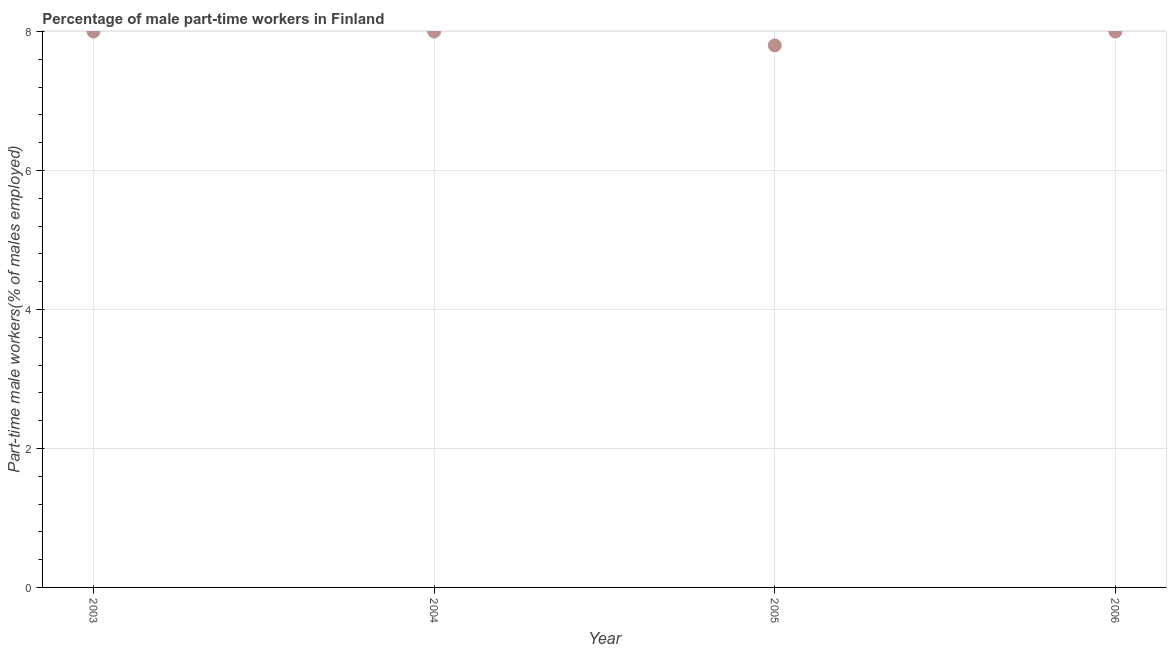What is the percentage of part-time male workers in 2005?
Give a very brief answer. 7.8. Across all years, what is the minimum percentage of part-time male workers?
Provide a short and direct response. 7.8. In which year was the percentage of part-time male workers minimum?
Your answer should be compact. 2005. What is the sum of the percentage of part-time male workers?
Provide a short and direct response. 31.8. What is the average percentage of part-time male workers per year?
Give a very brief answer. 7.95. What is the median percentage of part-time male workers?
Offer a terse response. 8. What is the ratio of the percentage of part-time male workers in 2003 to that in 2005?
Provide a short and direct response. 1.03. Is the percentage of part-time male workers in 2004 less than that in 2006?
Your answer should be compact. No. Is the sum of the percentage of part-time male workers in 2005 and 2006 greater than the maximum percentage of part-time male workers across all years?
Your answer should be compact. Yes. What is the difference between the highest and the lowest percentage of part-time male workers?
Provide a succinct answer. 0.2. In how many years, is the percentage of part-time male workers greater than the average percentage of part-time male workers taken over all years?
Make the answer very short. 3. Does the percentage of part-time male workers monotonically increase over the years?
Offer a very short reply. No. How many dotlines are there?
Ensure brevity in your answer.  1. What is the difference between two consecutive major ticks on the Y-axis?
Give a very brief answer. 2. Does the graph contain any zero values?
Offer a very short reply. No. Does the graph contain grids?
Make the answer very short. Yes. What is the title of the graph?
Your answer should be very brief. Percentage of male part-time workers in Finland. What is the label or title of the Y-axis?
Your response must be concise. Part-time male workers(% of males employed). What is the Part-time male workers(% of males employed) in 2004?
Provide a succinct answer. 8. What is the Part-time male workers(% of males employed) in 2005?
Offer a very short reply. 7.8. What is the difference between the Part-time male workers(% of males employed) in 2003 and 2004?
Your answer should be very brief. 0. What is the difference between the Part-time male workers(% of males employed) in 2003 and 2005?
Offer a terse response. 0.2. What is the difference between the Part-time male workers(% of males employed) in 2004 and 2005?
Provide a succinct answer. 0.2. 